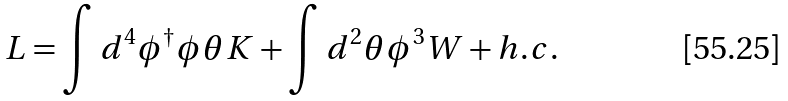Convert formula to latex. <formula><loc_0><loc_0><loc_500><loc_500>L = \int d ^ { 4 } \phi ^ { \dagger } \phi \theta K + \int d ^ { 2 } \theta \phi ^ { 3 } W + h . c .</formula> 